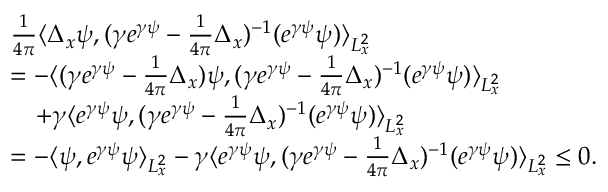<formula> <loc_0><loc_0><loc_500><loc_500>\begin{array} { r l } & { \frac { 1 } { 4 \pi } \langle \Delta _ { x } \psi , ( \gamma e ^ { \gamma \psi } - \frac { 1 } { 4 \pi } \Delta _ { x } ) ^ { - 1 } ( e ^ { \gamma \psi } \psi ) \rangle _ { L _ { x } ^ { 2 } } } \\ & { = - \langle ( \gamma e ^ { \gamma \psi } - \frac { 1 } { 4 \pi } \Delta _ { x } ) \psi , ( \gamma e ^ { \gamma \psi } - \frac { 1 } { 4 \pi } \Delta _ { x } ) ^ { - 1 } ( e ^ { \gamma \psi } \psi ) \rangle _ { L _ { x } ^ { 2 } } } \\ & { \quad + \gamma \langle e ^ { \gamma \psi } \psi , ( \gamma e ^ { \gamma \psi } - \frac { 1 } { 4 \pi } \Delta _ { x } ) ^ { - 1 } ( e ^ { \gamma \psi } \psi ) \rangle _ { L _ { x } ^ { 2 } } } \\ & { = - \langle \psi , e ^ { \gamma \psi } \psi \rangle _ { L _ { x } ^ { 2 } } - \gamma \langle e ^ { \gamma \psi } \psi , ( \gamma e ^ { \gamma \psi } - \frac { 1 } { 4 \pi } \Delta _ { x } ) ^ { - 1 } ( e ^ { \gamma \psi } \psi ) \rangle _ { L _ { x } ^ { 2 } } \leq 0 . } \end{array}</formula> 